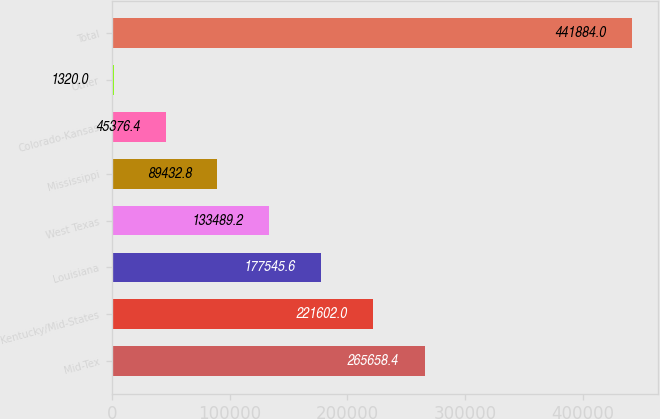Convert chart. <chart><loc_0><loc_0><loc_500><loc_500><bar_chart><fcel>Mid-Tex<fcel>Kentucky/Mid-States<fcel>Louisiana<fcel>West Texas<fcel>Mississippi<fcel>Colorado-Kansas<fcel>Other<fcel>Total<nl><fcel>265658<fcel>221602<fcel>177546<fcel>133489<fcel>89432.8<fcel>45376.4<fcel>1320<fcel>441884<nl></chart> 